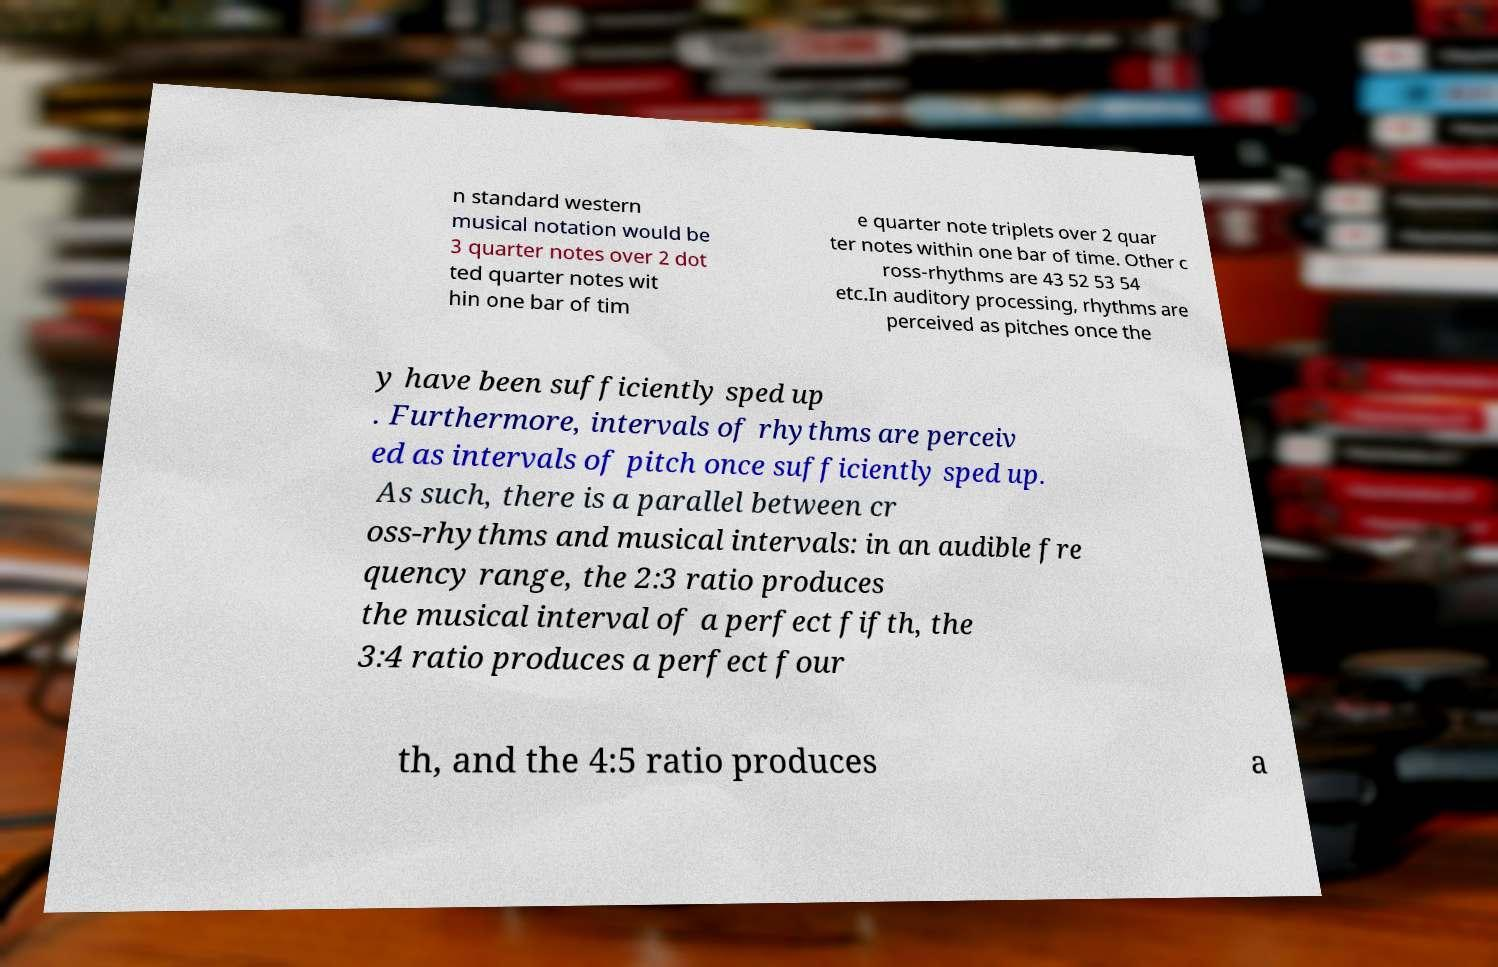What messages or text are displayed in this image? I need them in a readable, typed format. n standard western musical notation would be 3 quarter notes over 2 dot ted quarter notes wit hin one bar of tim e quarter note triplets over 2 quar ter notes within one bar of time. Other c ross-rhythms are 43 52 53 54 etc.In auditory processing, rhythms are perceived as pitches once the y have been sufficiently sped up . Furthermore, intervals of rhythms are perceiv ed as intervals of pitch once sufficiently sped up. As such, there is a parallel between cr oss-rhythms and musical intervals: in an audible fre quency range, the 2:3 ratio produces the musical interval of a perfect fifth, the 3:4 ratio produces a perfect four th, and the 4:5 ratio produces a 